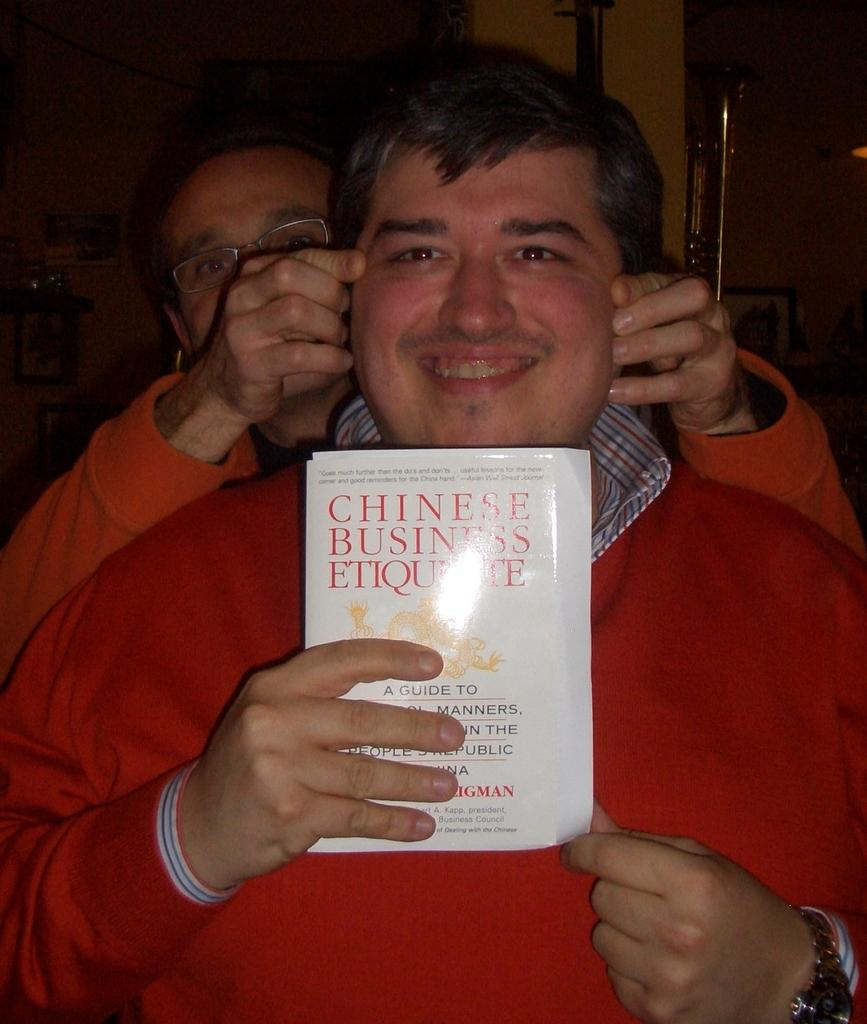How many people are in the image? There are two men in the image. What is one of the men holding? One of the men is holding a book. What can be observed about the background of the image? The background of the image is dark. What type of copper object is visible in the pocket of one of the men in the image? There is no copper object visible in the pocket of either man in the image. 